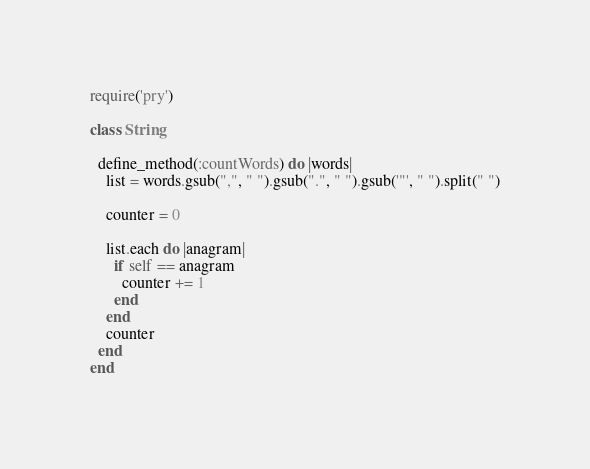Convert code to text. <code><loc_0><loc_0><loc_500><loc_500><_Ruby_>require('pry')

class String

  define_method(:countWords) do |words|
    list = words.gsub(",", " ").gsub(".", " ").gsub('"', " ").split(" ")

    counter = 0

    list.each do |anagram|
      if self == anagram
        counter += 1
      end
    end
    counter
  end
end
</code> 